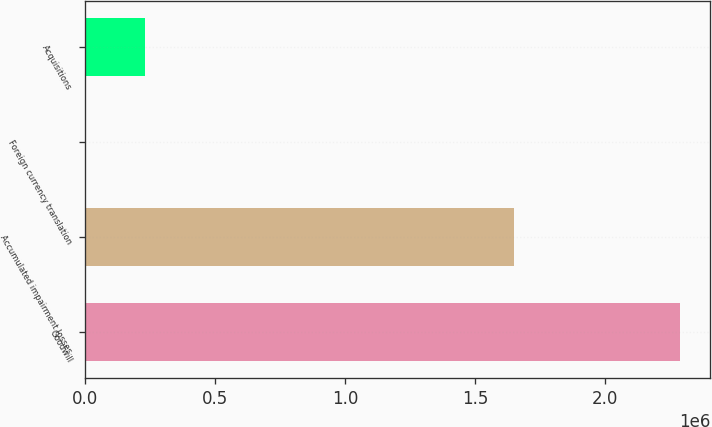<chart> <loc_0><loc_0><loc_500><loc_500><bar_chart><fcel>Goodwill<fcel>Accumulated impairment losses<fcel>Foreign currency translation<fcel>Acquisitions<nl><fcel>2.28942e+06<fcel>1.65032e+06<fcel>1617<fcel>230397<nl></chart> 